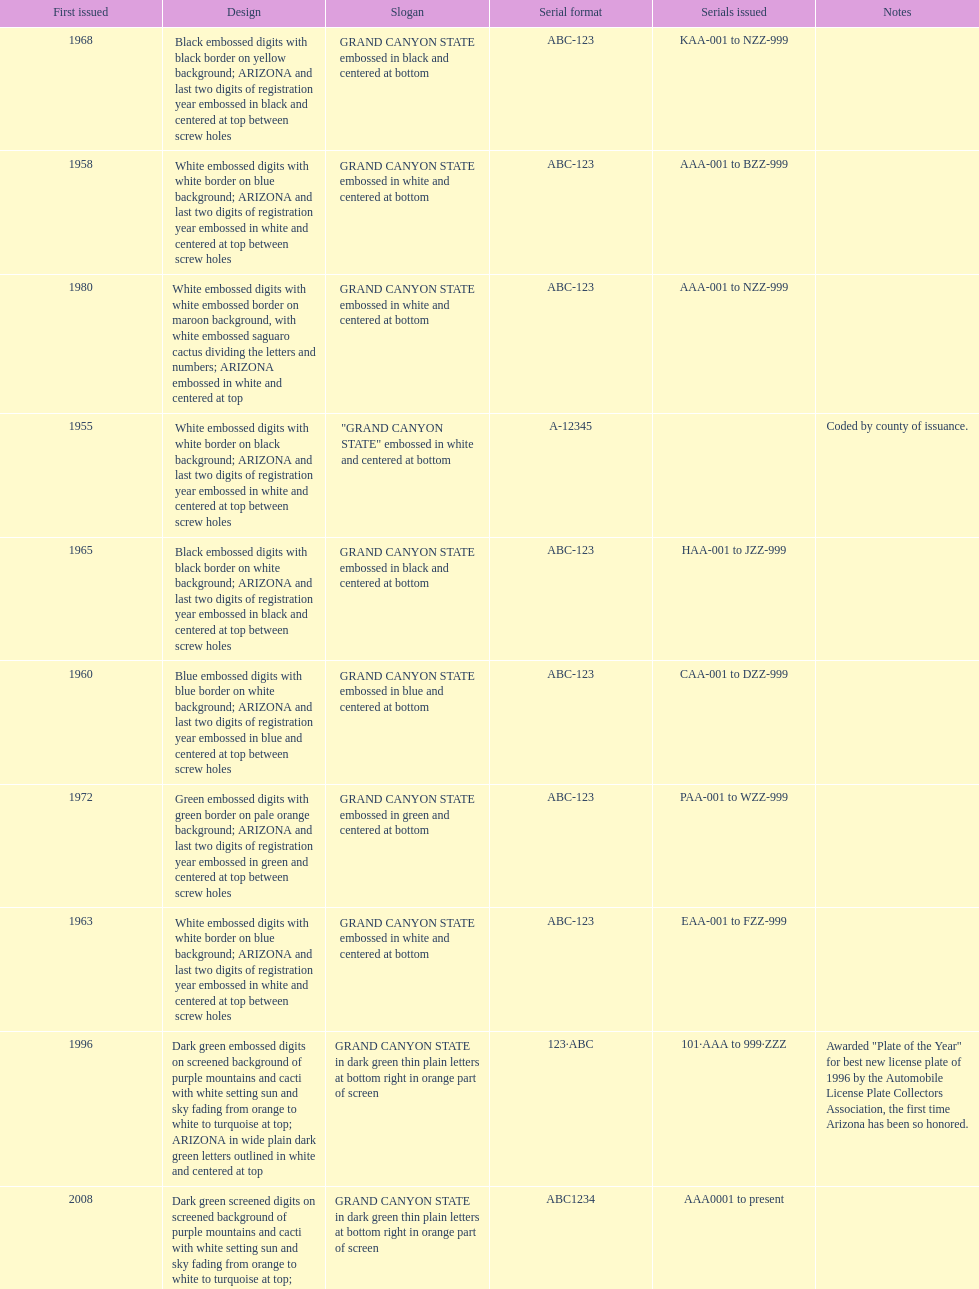Which year featured the license plate with the least characters? 1955. 